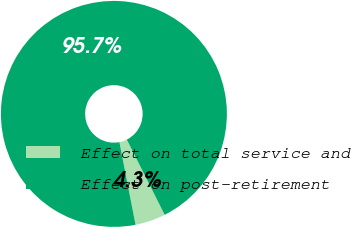Convert chart to OTSL. <chart><loc_0><loc_0><loc_500><loc_500><pie_chart><fcel>Effect on total service and<fcel>Effect on post-retirement<nl><fcel>4.35%<fcel>95.65%<nl></chart> 